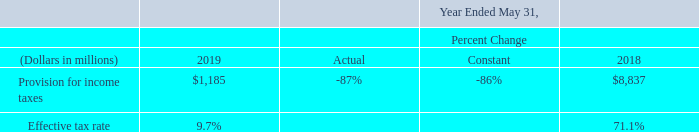Provision for Income Taxes: Our effective income tax rates for each of the periods presented were the result of the mix of income earned in various tax jurisdictions that apply a broad range of income tax rates. In fiscal 2018, the Tax Act was signed into law. The more significant provisions of the Tax Act as applicable to us are described above under “Impacts of the U.S. Tax Cuts and Jobs Act of 2017”. refer to Note 14 of Notes to Consolidated Financial Statements included elsewhere in this Annual report for a discussion regarding the differences between the effective income tax rates as presented for the periods below and the U.S. federal statutory income tax rates that were in effect during these periods. Future effective income tax rates could be adversely affected by an unfavorable shift of earnings weighted to jurisdictions with higher tax rates, by unfavorable changes in tax laws and regulations, by adverse rulings in tax related litigation, or by shortfalls in stock-based compensation realized by employees relative to stock-based compensation that was recorded for book purposes, among others.
Provision for income taxes decreased in fiscal 2019 relative to fiscal 2018 primarily due to the absence of the initial accounting charges related to the Tax Act that were recorded in fiscal 2018. To a lesser extent, provision for income taxes also decreased in fiscal 2019 due to the net favorable impacts of our final accounting for the Tax Act in fiscal 2019; the net favorable impacts of the Tax Act on our tax profile during fiscal 2019; the favorable impact of a tax benefit arising from an increase in a deferred tax asset associated with a partial realignment of our legal structure in fiscal 2019; and lower income before provision for income taxes in fiscal 2019. These decreases to our provision for income taxes in fiscal 2019 relative to fiscal 2018 were partially offset both by lower excess tax benefits related to stock-based compensation expense in fiscal 2019, and by less favorable changes in net unrecognized tax benefits due to settlements with tax authorities and other events in fiscal 2019 relative to fiscal 2018.
How much was the average effective tax rate in 2018 and 2019?
Answer scale should be: percent. (9.7+71.1) / 2 
Answer: 40.4. By how much less was the provision for income taxes in 2019 compared to 2018?
Answer scale should be: million. 8,837 - 1,185 
Answer: 7652. How much was the total provision for income taxes across 2018 and 2019?
Answer scale should be: million. 1,185 + 8,837 
Answer: 10022. Which section of the Tax Act is most significant to Oracle? Impacts of the u.s. tax cuts and jobs act of 2017. What are some reasons provided for possible adverse impact on effective income tax rates? Future effective income tax rates could be adversely affected by an unfavorable shift of earnings weighted to jurisdictions with higher tax rates, by unfavorable changes in tax laws and regulations, by adverse rulings in tax related litigation, or by shortfalls in stock-based compensation realized by employees relative to stock-based compensation that was recorded for book purposes, among others. Why did the company's provision for income taxes not decrease as much in fiscal 2019 as expected? These decreases to our provision for income taxes in fiscal 2019 relative to fiscal 2018 were partially offset both by lower excess tax benefits related to stock-based compensation expense in fiscal 2019, and by less favorable changes in net unrecognized tax benefits due to settlements with tax authorities and other events in fiscal 2019 relative to fiscal 2018. 